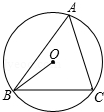Please describe any geometric theorems that could be applied to this circle diagram involving points O, B, and C. In the given circle diagram, several theorems apply. One key theorem is the Inscribed Angle Theorem, which suggests that the angle OBC inscribed in the circle would measure half the arc that it subtends. Another applicable theorem is the Intersecting Secants Theorem, which states that the angle formed by two intersecting secants is half the sum of the arcs opposite these secants. 